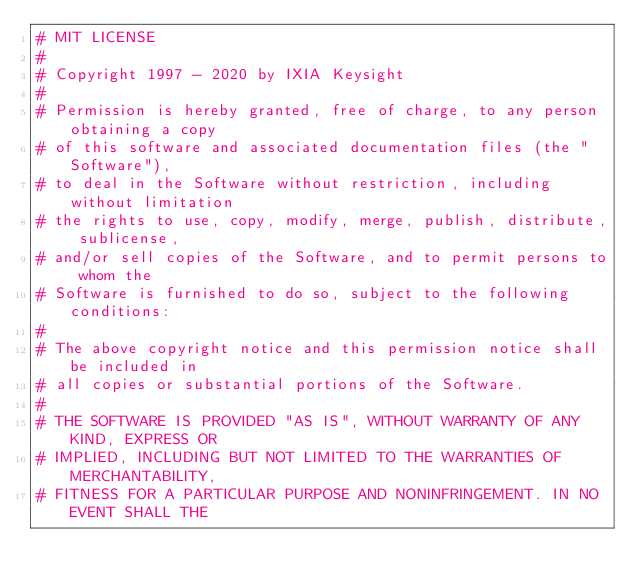<code> <loc_0><loc_0><loc_500><loc_500><_Python_># MIT LICENSE
#
# Copyright 1997 - 2020 by IXIA Keysight
#
# Permission is hereby granted, free of charge, to any person obtaining a copy
# of this software and associated documentation files (the "Software"),
# to deal in the Software without restriction, including without limitation
# the rights to use, copy, modify, merge, publish, distribute, sublicense,
# and/or sell copies of the Software, and to permit persons to whom the
# Software is furnished to do so, subject to the following conditions:
#
# The above copyright notice and this permission notice shall be included in
# all copies or substantial portions of the Software.
#
# THE SOFTWARE IS PROVIDED "AS IS", WITHOUT WARRANTY OF ANY KIND, EXPRESS OR
# IMPLIED, INCLUDING BUT NOT LIMITED TO THE WARRANTIES OF MERCHANTABILITY,
# FITNESS FOR A PARTICULAR PURPOSE AND NONINFRINGEMENT. IN NO EVENT SHALL THE</code> 